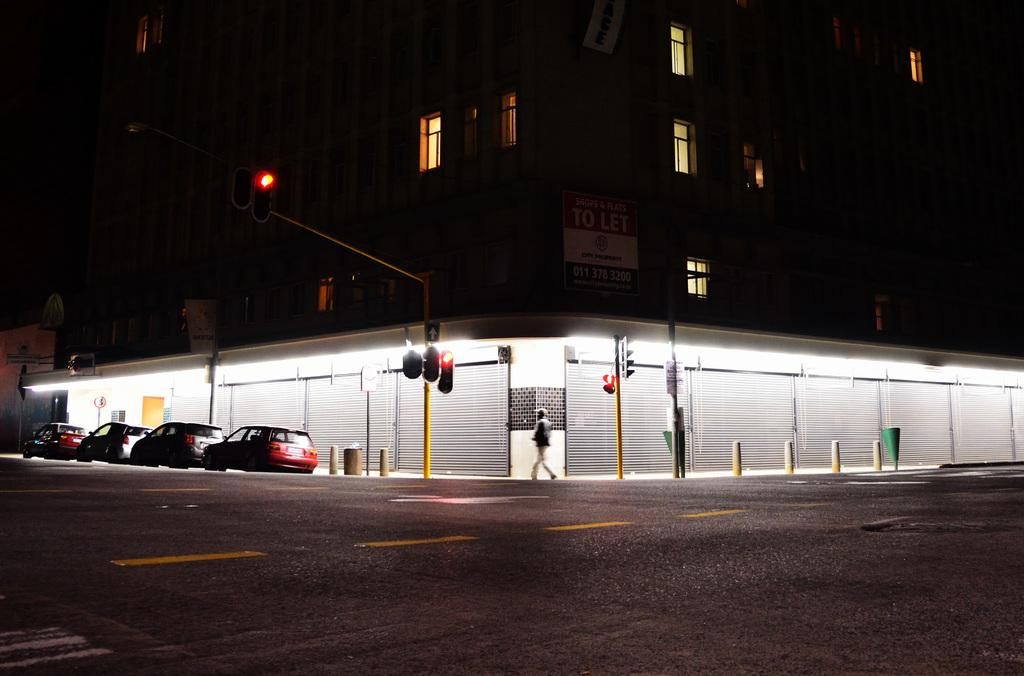What is the person in the image doing? The person is walking in the image. On what surface is the person walking? The person is walking on the pavement. What can be seen attached to poles in the image? There are traffic lights attached to poles in the image. What is present on the left side of the image? There are vehicles on the road on the left side of the image. What can be seen in the background of the image? There are buildings in the background of the image. What type of bears can be seen interacting with the traffic lights in the image? There are no bears present in the image; it features a person walking on the pavement and traffic lights attached to poles. What material is used to cover the buildings in the image? The provided facts do not mention any specific material used to cover the buildings in the image. 